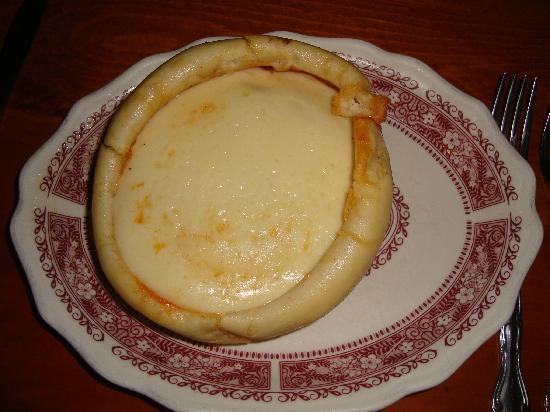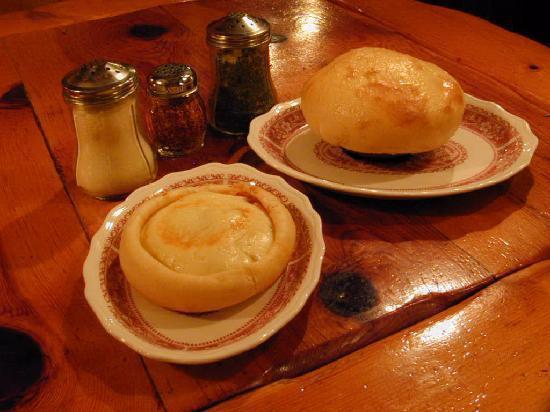The first image is the image on the left, the second image is the image on the right. Examine the images to the left and right. Is the description "Both images show soup in a bread bowl." accurate? Answer yes or no. Yes. 